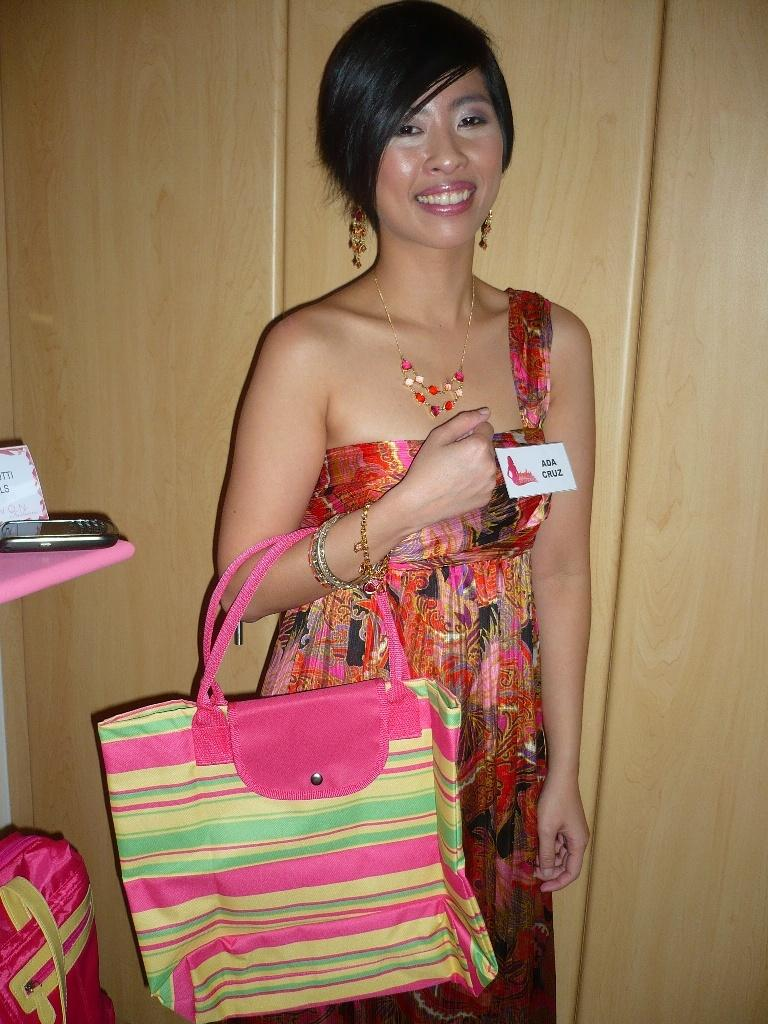Who is the main subject in the image? There is a woman in the center of the image. What is the woman in the center of the image doing? The woman is smiling. Can you describe the other woman in the image? The other woman is holding a bag. What color is the bag visible in the background? There is a pink bag visible in the background. What electronic device can be seen in the background? A phone is present in the background. What other objects can be seen in the background? There are additional objects visible in the background. What type of marble is being used to create the juice in the image? There is no marble or juice present in the image. What is the judge doing in the image? There is no judge present in the image. 